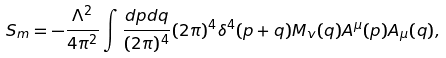<formula> <loc_0><loc_0><loc_500><loc_500>S _ { m } = - \frac { \Lambda ^ { 2 } } { 4 \pi ^ { 2 } } \int \frac { d p d q } { ( 2 \pi ) ^ { 4 } } ( 2 \pi ) ^ { 4 } \delta ^ { 4 } ( p + q ) M _ { v } ( q ) A ^ { \mu } ( p ) A _ { \mu } ( q ) ,</formula> 